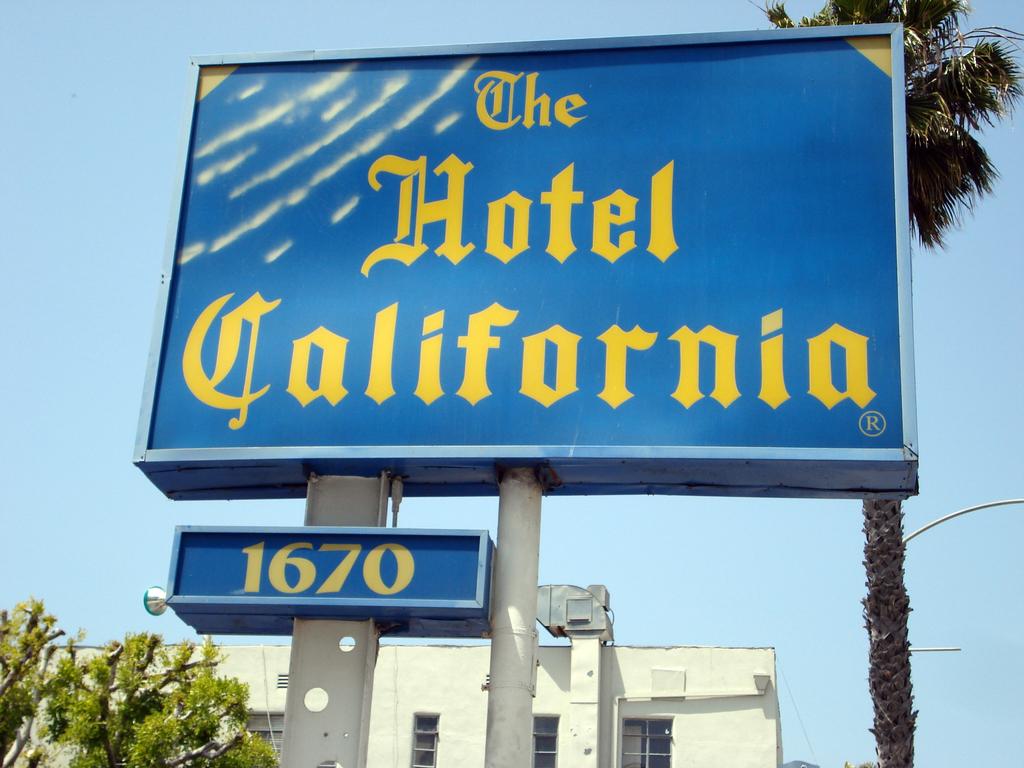What is the address of the hotel?
Your answer should be compact. 1670. What is the name of the hotel?
Make the answer very short. The hotel california. 